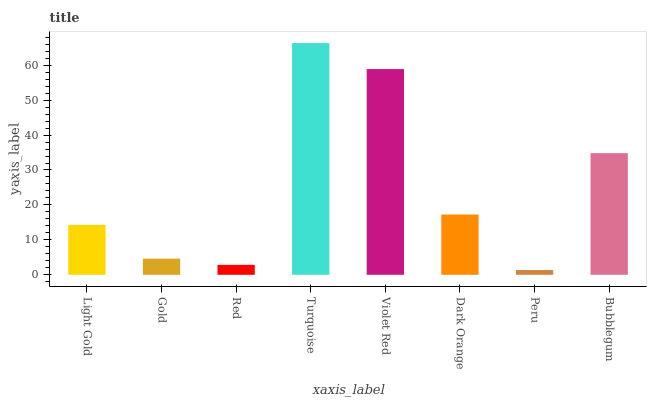Is Peru the minimum?
Answer yes or no. Yes. Is Turquoise the maximum?
Answer yes or no. Yes. Is Gold the minimum?
Answer yes or no. No. Is Gold the maximum?
Answer yes or no. No. Is Light Gold greater than Gold?
Answer yes or no. Yes. Is Gold less than Light Gold?
Answer yes or no. Yes. Is Gold greater than Light Gold?
Answer yes or no. No. Is Light Gold less than Gold?
Answer yes or no. No. Is Dark Orange the high median?
Answer yes or no. Yes. Is Light Gold the low median?
Answer yes or no. Yes. Is Bubblegum the high median?
Answer yes or no. No. Is Violet Red the low median?
Answer yes or no. No. 